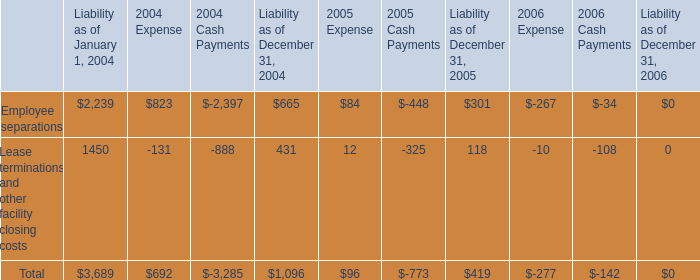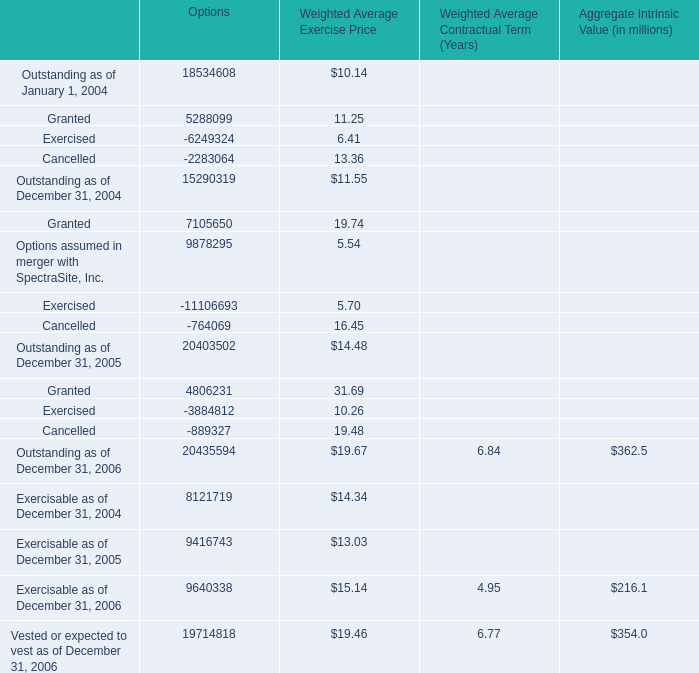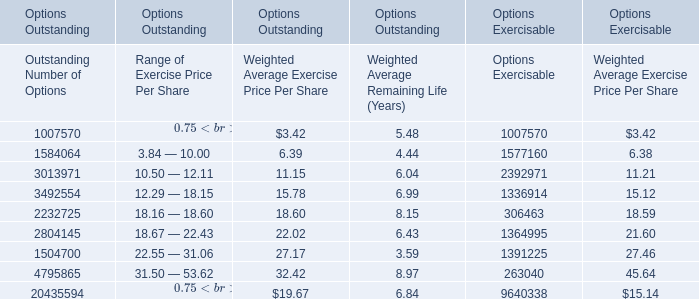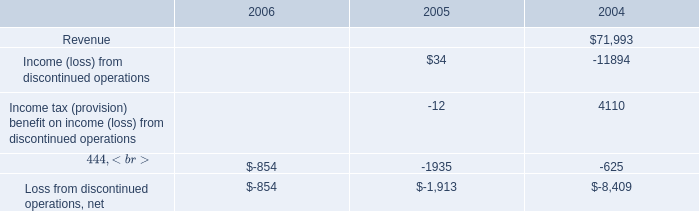What is the average amount of Options assumed in merger with SpectraSite, Inc. of Options, and 3013971 of Options Exercisable ? 
Computations: ((9878295.0 + 2392971.0) / 2)
Answer: 6135633.0. 